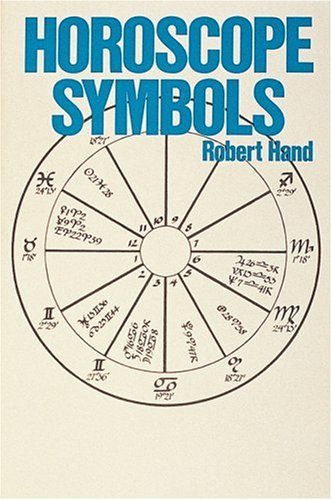Is this a kids book? No, this is not a kids’ book. It is intended for individuals with an interest in astrology, mostly adults, as it contains complex interpretations of astrological symbols. 